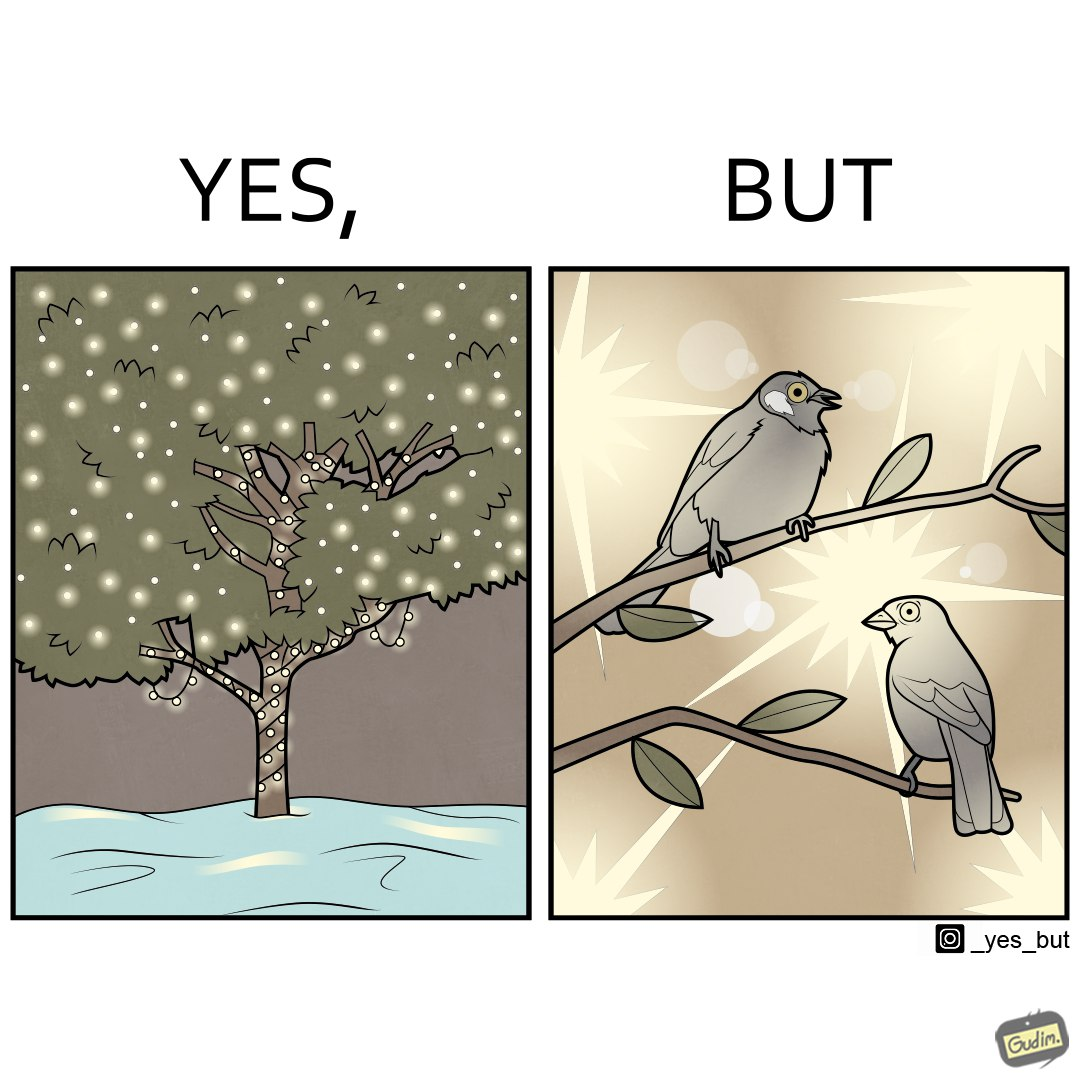What is shown in this image? The images are ironic since they show how putting a lot of lights as decorations on trees make them beautiful to look at for us but cause trouble to the birds who actually live on trees for no good reason 